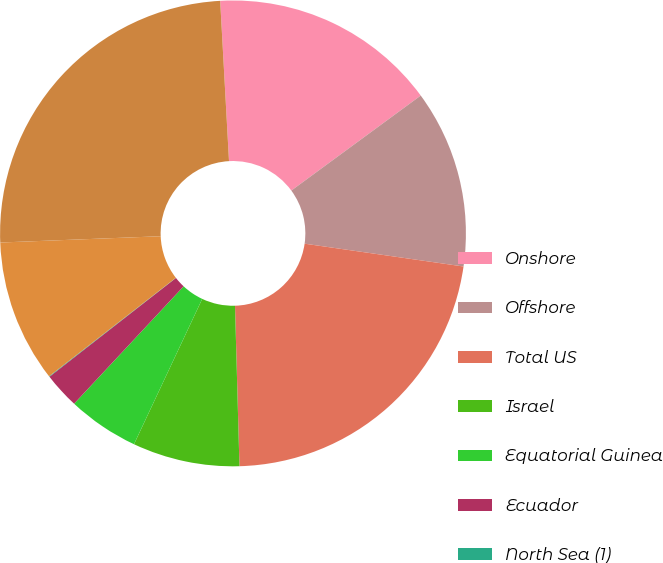Convert chart. <chart><loc_0><loc_0><loc_500><loc_500><pie_chart><fcel>Onshore<fcel>Offshore<fcel>Total US<fcel>Israel<fcel>Equatorial Guinea<fcel>Ecuador<fcel>North Sea (1)<fcel>Total International<fcel>Total Worldwide (2)<nl><fcel>15.8%<fcel>12.35%<fcel>22.29%<fcel>7.43%<fcel>4.96%<fcel>2.5%<fcel>0.04%<fcel>9.89%<fcel>24.75%<nl></chart> 